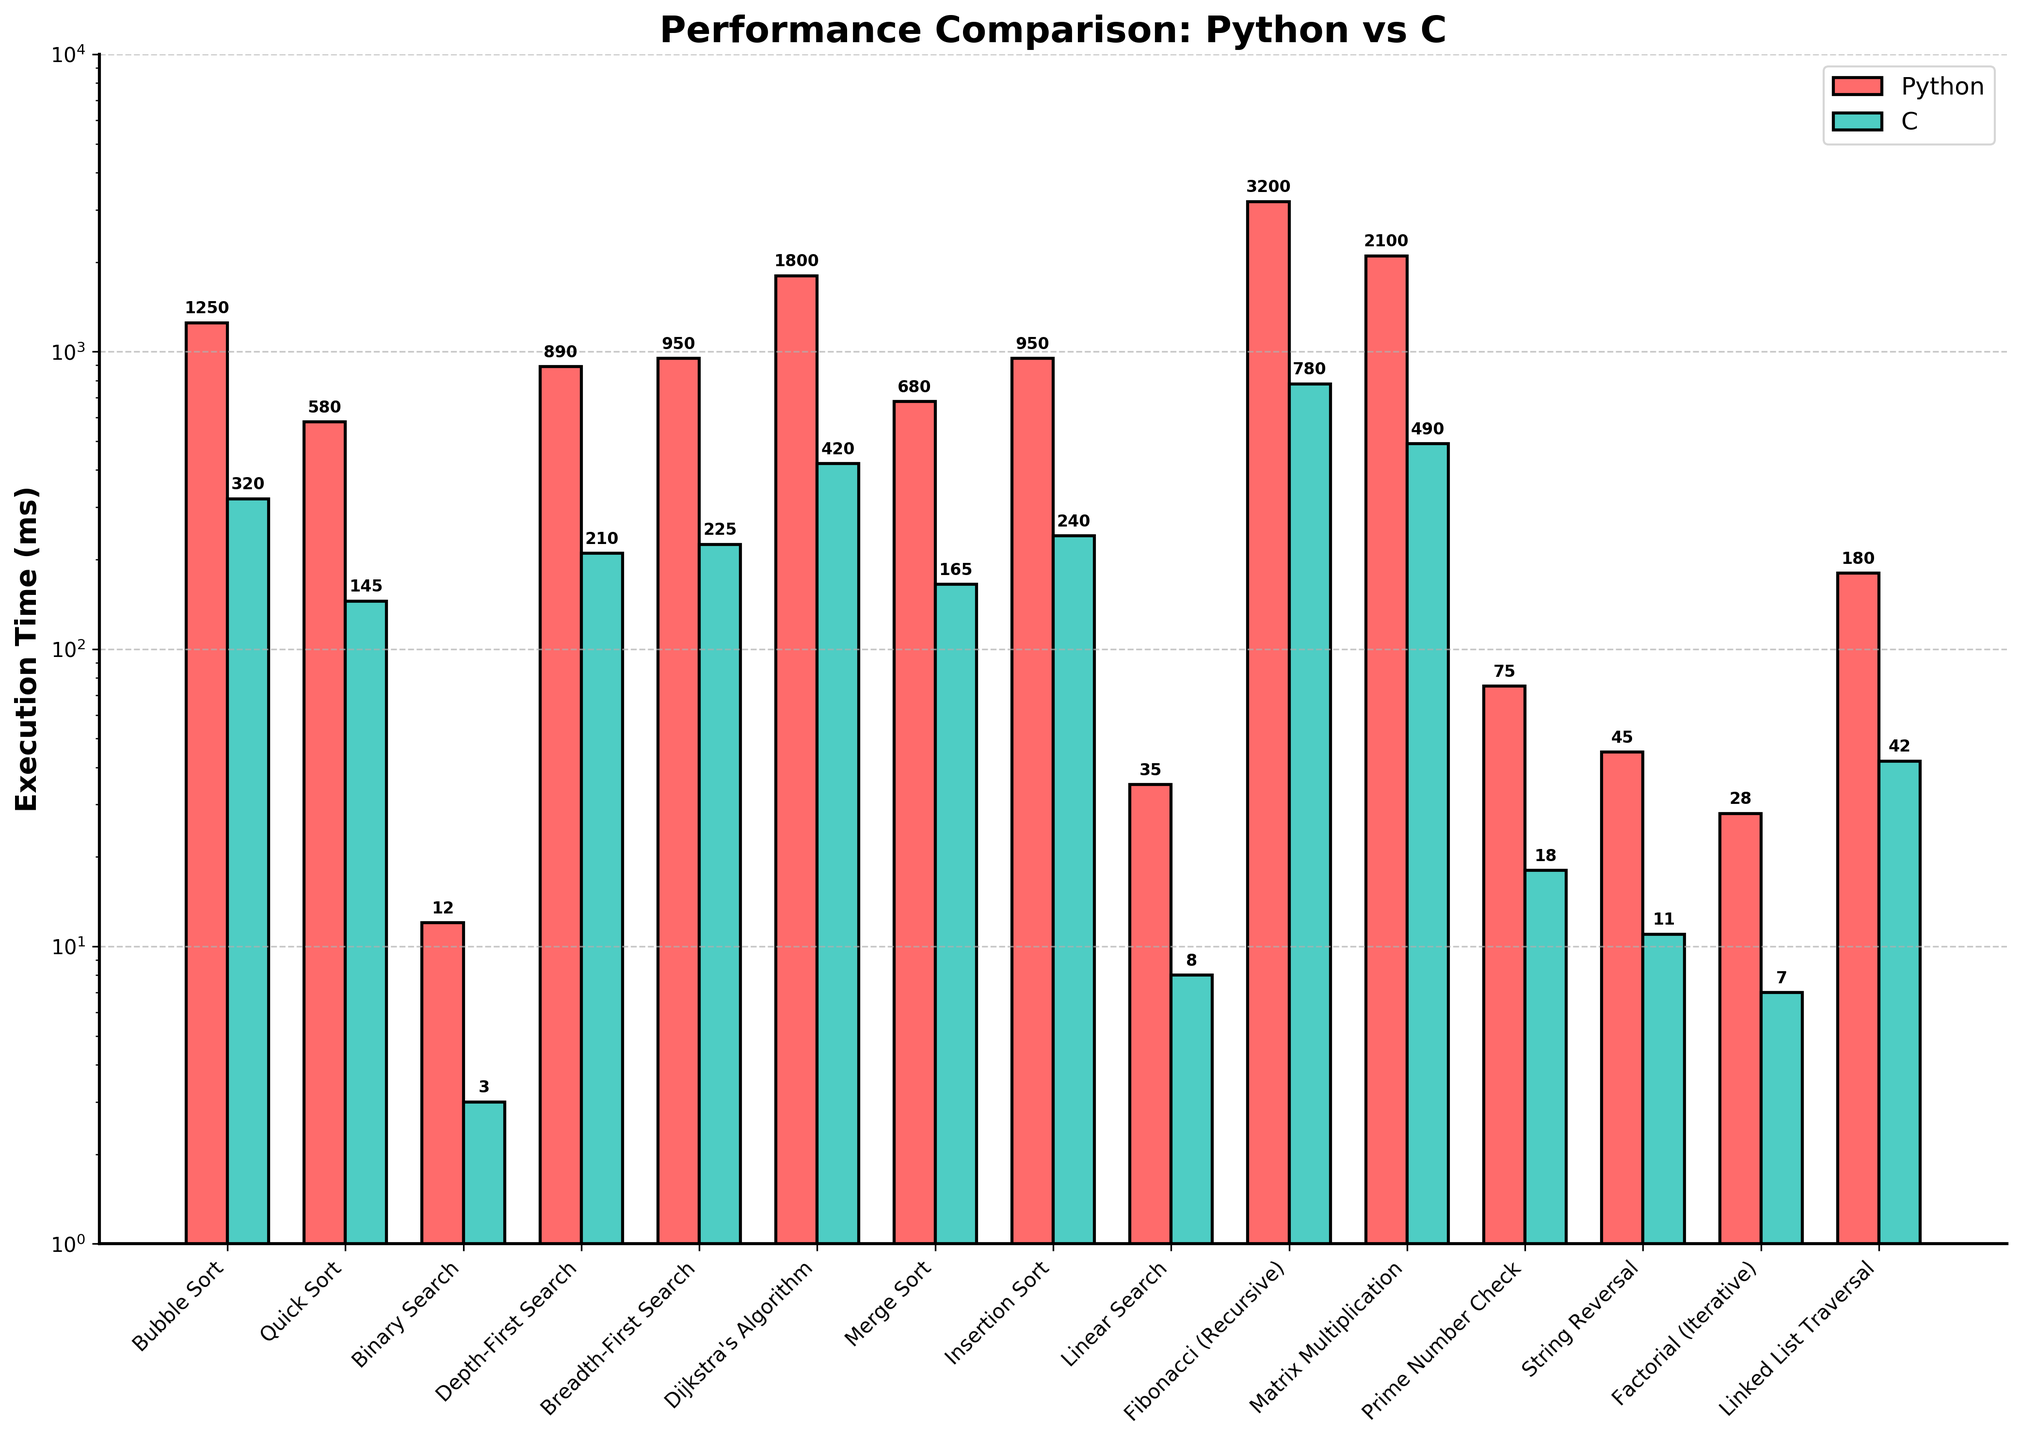Which algorithm shows the largest performance difference between Python and C? The largest performance difference can be identified by comparing the heights of the bars for each algorithm in the chart. The Fibonacci (Recursive) algorithm exhibits the most significant performance difference, with Python significantly slower than C.
Answer: Fibonacci (Recursive) What is the execution time difference for Bubble Sort between Python and C? Find the heights of the bars for Bubble Sort. Python execution time is 1250 ms, and C execution time is 320 ms. The difference is 1250 - 320.
Answer: 930 ms Which algorithm is the fastest in C and what is its execution time? The fastest algorithm in C can be found by identifying the shortest green bar in the chart. The Binary Search algorithm has the shortest execution time in C.
Answer: Binary Search, 3 ms How much faster is Quick Sort in C compared to Python? Find the heights of the bars for Quick Sort. Python execution time is 580 ms, and C execution time is 145 ms. The difference is 580 - 145, and C is thus 435 ms faster than Python.
Answer: 435 ms What is the average execution time of all algorithms in C? Sum the execution times for all algorithms in C and divide by the number of algorithms. Sum = 320 + 145 + 3 + 210 + 225 + 420 + 165 + 240 + 8 + 780 + 490 + 18 + 11 + 7 + 42. Average = Sum / 15 = 3094 / 15.
Answer: 206.27 ms Which algorithm takes the longest time to execute in Python? The algorithm with the tallest red bar represents the longest execution time in Python. The Fibonacci (Recursive) has the highest value at 3200 ms.
Answer: Fibonacci (Recursive) Compare the execution time of Depth-First Search vs. Breadth-First Search in Python and C. Which algorithm is more efficient in each language? For Python, compare the heights of the red bars for Depth-First Search (890 ms) and Breadth-First Search (950 ms). For C, compare the heights of the green bars for Depth-First Search (210 ms) and Breadth-First Search (225 ms). Depth-First Search is more efficient in both Python and C.
Answer: Depth-First Search What is the total execution time for all sorting algorithms in Python? Sum the execution times for Bubble Sort, Quick Sort, Merge Sort, and Insertion Sort in Python, which are 1250, 580, 680, and 950 ms respectively. The total is 1250 + 580 + 680 + 950.
Answer: 3460 ms Which algorithm shows the smallest performance improvement when switching from Python to C? The smallest performance improvement is found by comparing the ratios of execution times for each algorithm. The Prime Number Check has the smallest improvement, with Python taking 75 ms and C taking 18 ms.
Answer: Prime Number Check Which algorithm's execution time in Python is closest to the execution time of Matrix Multiplication in C? Matrix Multiplication in C has an execution time of 490 ms. Compare this to Python execution times. Merge Sort at 680 ms is the closest to 490 ms.
Answer: Merge Sort 